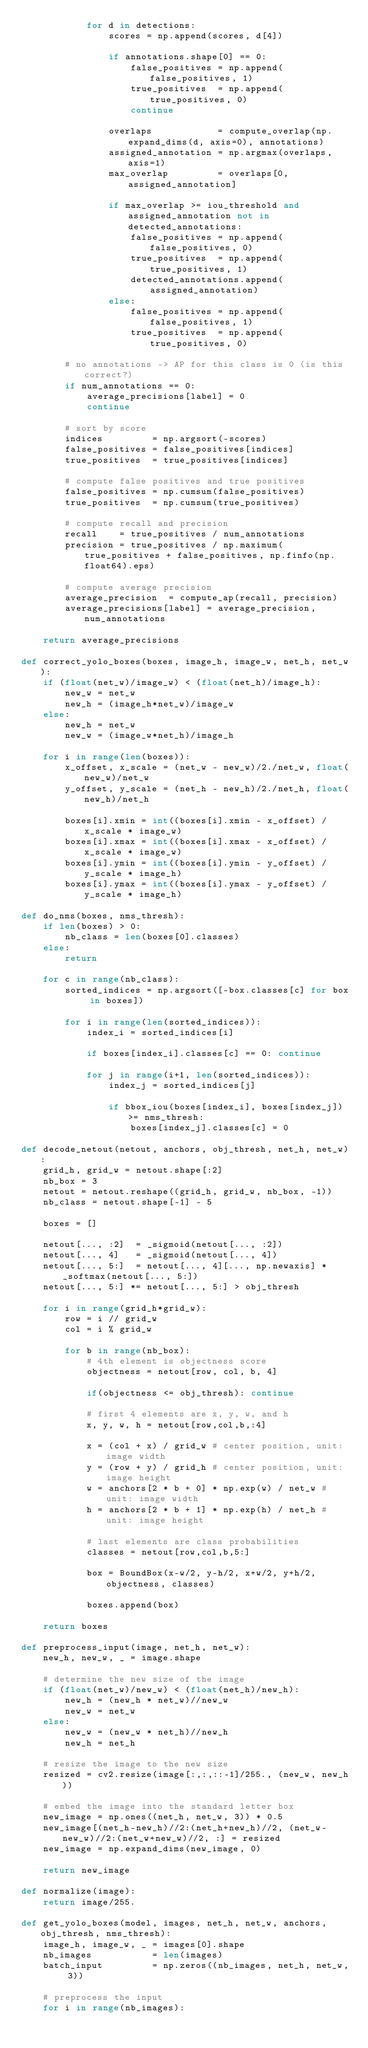Convert code to text. <code><loc_0><loc_0><loc_500><loc_500><_Python_>            for d in detections:
                scores = np.append(scores, d[4])

                if annotations.shape[0] == 0:
                    false_positives = np.append(false_positives, 1)
                    true_positives  = np.append(true_positives, 0)
                    continue

                overlaps            = compute_overlap(np.expand_dims(d, axis=0), annotations)
                assigned_annotation = np.argmax(overlaps, axis=1)
                max_overlap         = overlaps[0, assigned_annotation]

                if max_overlap >= iou_threshold and assigned_annotation not in detected_annotations:
                    false_positives = np.append(false_positives, 0)
                    true_positives  = np.append(true_positives, 1)
                    detected_annotations.append(assigned_annotation)
                else:
                    false_positives = np.append(false_positives, 1)
                    true_positives  = np.append(true_positives, 0)

        # no annotations -> AP for this class is 0 (is this correct?)
        if num_annotations == 0:
            average_precisions[label] = 0
            continue

        # sort by score
        indices         = np.argsort(-scores)
        false_positives = false_positives[indices]
        true_positives  = true_positives[indices]

        # compute false positives and true positives
        false_positives = np.cumsum(false_positives)
        true_positives  = np.cumsum(true_positives)

        # compute recall and precision
        recall    = true_positives / num_annotations
        precision = true_positives / np.maximum(true_positives + false_positives, np.finfo(np.float64).eps)

        # compute average precision
        average_precision  = compute_ap(recall, precision)
        average_precisions[label] = average_precision,num_annotations

    return average_precisions

def correct_yolo_boxes(boxes, image_h, image_w, net_h, net_w):
    if (float(net_w)/image_w) < (float(net_h)/image_h):
        new_w = net_w
        new_h = (image_h*net_w)/image_w
    else:
        new_h = net_w
        new_w = (image_w*net_h)/image_h

    for i in range(len(boxes)):
        x_offset, x_scale = (net_w - new_w)/2./net_w, float(new_w)/net_w
        y_offset, y_scale = (net_h - new_h)/2./net_h, float(new_h)/net_h

        boxes[i].xmin = int((boxes[i].xmin - x_offset) / x_scale * image_w)
        boxes[i].xmax = int((boxes[i].xmax - x_offset) / x_scale * image_w)
        boxes[i].ymin = int((boxes[i].ymin - y_offset) / y_scale * image_h)
        boxes[i].ymax = int((boxes[i].ymax - y_offset) / y_scale * image_h)

def do_nms(boxes, nms_thresh):
    if len(boxes) > 0:
        nb_class = len(boxes[0].classes)
    else:
        return

    for c in range(nb_class):
        sorted_indices = np.argsort([-box.classes[c] for box in boxes])

        for i in range(len(sorted_indices)):
            index_i = sorted_indices[i]

            if boxes[index_i].classes[c] == 0: continue

            for j in range(i+1, len(sorted_indices)):
                index_j = sorted_indices[j]

                if bbox_iou(boxes[index_i], boxes[index_j]) >= nms_thresh:
                    boxes[index_j].classes[c] = 0

def decode_netout(netout, anchors, obj_thresh, net_h, net_w):
    grid_h, grid_w = netout.shape[:2]
    nb_box = 3
    netout = netout.reshape((grid_h, grid_w, nb_box, -1))
    nb_class = netout.shape[-1] - 5

    boxes = []

    netout[..., :2]  = _sigmoid(netout[..., :2])
    netout[..., 4]   = _sigmoid(netout[..., 4])
    netout[..., 5:]  = netout[..., 4][..., np.newaxis] * _softmax(netout[..., 5:])
    netout[..., 5:] *= netout[..., 5:] > obj_thresh

    for i in range(grid_h*grid_w):
        row = i // grid_w
        col = i % grid_w

        for b in range(nb_box):
            # 4th element is objectness score
            objectness = netout[row, col, b, 4]

            if(objectness <= obj_thresh): continue

            # first 4 elements are x, y, w, and h
            x, y, w, h = netout[row,col,b,:4]

            x = (col + x) / grid_w # center position, unit: image width
            y = (row + y) / grid_h # center position, unit: image height
            w = anchors[2 * b + 0] * np.exp(w) / net_w # unit: image width
            h = anchors[2 * b + 1] * np.exp(h) / net_h # unit: image height

            # last elements are class probabilities
            classes = netout[row,col,b,5:]

            box = BoundBox(x-w/2, y-h/2, x+w/2, y+h/2, objectness, classes)

            boxes.append(box)

    return boxes

def preprocess_input(image, net_h, net_w):
    new_h, new_w, _ = image.shape

    # determine the new size of the image
    if (float(net_w)/new_w) < (float(net_h)/new_h):
        new_h = (new_h * net_w)//new_w
        new_w = net_w
    else:
        new_w = (new_w * net_h)//new_h
        new_h = net_h

    # resize the image to the new size
    resized = cv2.resize(image[:,:,::-1]/255., (new_w, new_h))

    # embed the image into the standard letter box
    new_image = np.ones((net_h, net_w, 3)) * 0.5
    new_image[(net_h-new_h)//2:(net_h+new_h)//2, (net_w-new_w)//2:(net_w+new_w)//2, :] = resized
    new_image = np.expand_dims(new_image, 0)

    return new_image

def normalize(image):
    return image/255.

def get_yolo_boxes(model, images, net_h, net_w, anchors, obj_thresh, nms_thresh):
    image_h, image_w, _ = images[0].shape
    nb_images           = len(images)
    batch_input         = np.zeros((nb_images, net_h, net_w, 3))

    # preprocess the input
    for i in range(nb_images):</code> 